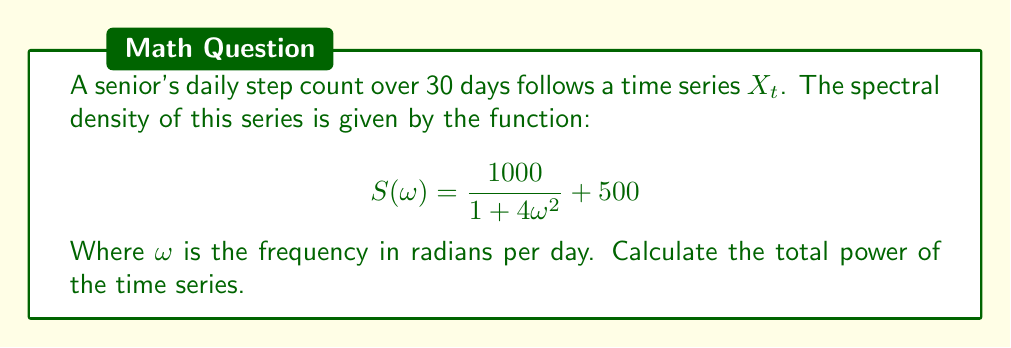What is the answer to this math problem? To find the total power of the time series, we need to integrate the spectral density function over all frequencies. In this case, we'll integrate from $-\infty$ to $\infty$.

Step 1: Set up the integral
$$\text{Total Power} = \int_{-\infty}^{\infty} S(\omega) d\omega$$

Step 2: Substitute the given spectral density function
$$\text{Total Power} = \int_{-\infty}^{\infty} \left(\frac{1000}{1 + 4\omega^2} + 500\right) d\omega$$

Step 3: Split the integral
$$\text{Total Power} = \int_{-\infty}^{\infty} \frac{1000}{1 + 4\omega^2} d\omega + \int_{-\infty}^{\infty} 500 d\omega$$

Step 4: Evaluate the first integral
The first integral is of the form $\frac{a}{1 + b^2x^2}$, which has the antiderivative $\frac{a}{b} \arctan(bx)$.

$$\int_{-\infty}^{\infty} \frac{1000}{1 + 4\omega^2} d\omega = 1000 \cdot \frac{1}{2} \left[\arctan(2\omega)\right]_{-\infty}^{\infty} = 1000 \cdot \frac{\pi}{2}$$

Step 5: Evaluate the second integral
The second integral diverges to infinity, as we're integrating a constant over an infinite interval.

$$\int_{-\infty}^{\infty} 500 d\omega = \infty$$

Step 6: Combine the results
The total power is the sum of these two integrals, which is infinite due to the second integral.

$$\text{Total Power} = 1000 \cdot \frac{\pi}{2} + \infty = \infty$$
Answer: $\infty$ 